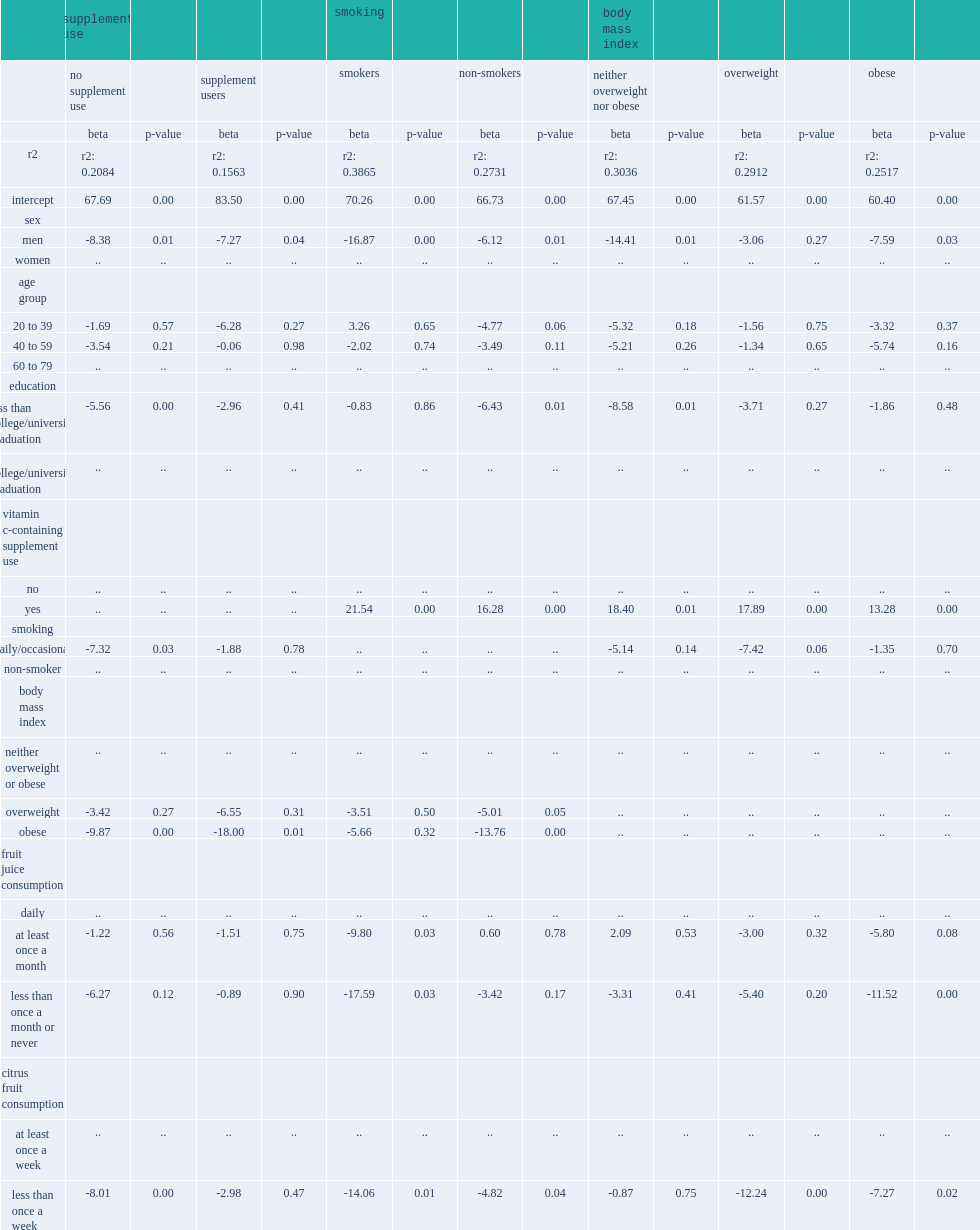In all multivariate models except the overweight population, which gender had significantly lower vitamin c concentrations, men or women? Men. 